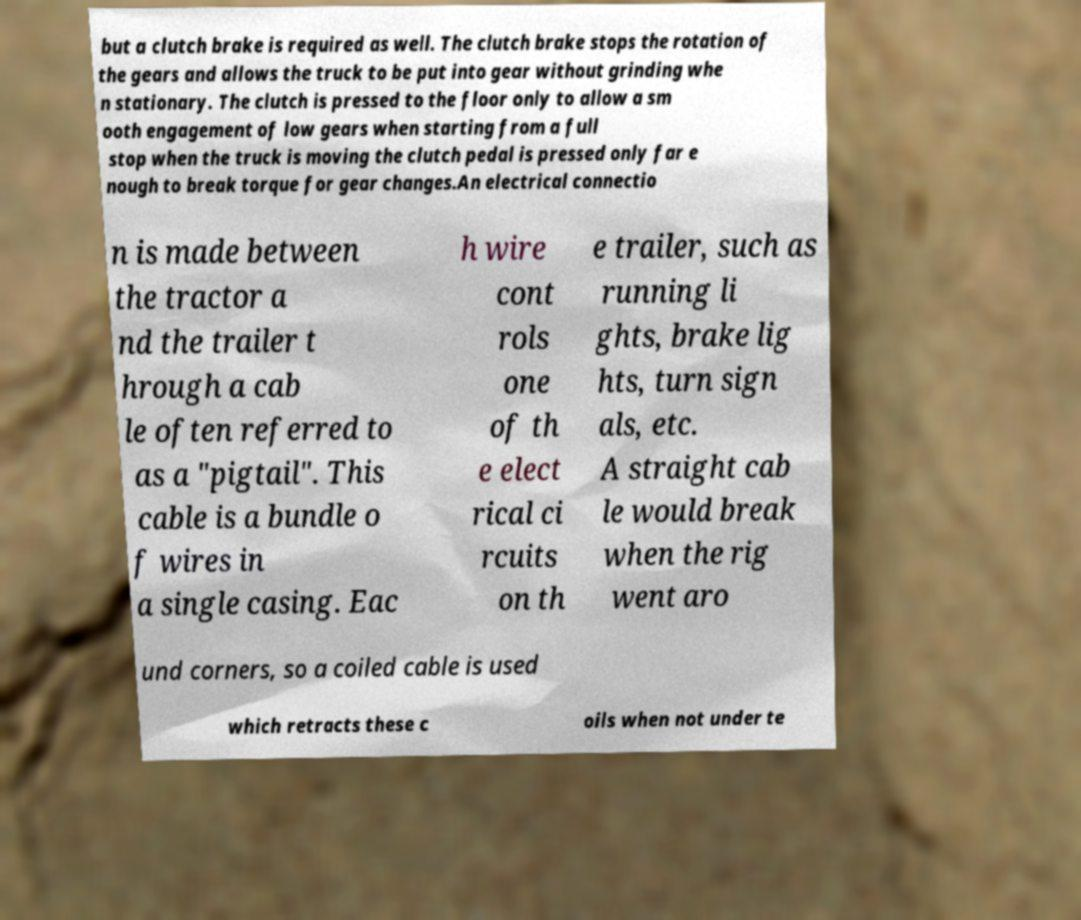Please read and relay the text visible in this image. What does it say? but a clutch brake is required as well. The clutch brake stops the rotation of the gears and allows the truck to be put into gear without grinding whe n stationary. The clutch is pressed to the floor only to allow a sm ooth engagement of low gears when starting from a full stop when the truck is moving the clutch pedal is pressed only far e nough to break torque for gear changes.An electrical connectio n is made between the tractor a nd the trailer t hrough a cab le often referred to as a "pigtail". This cable is a bundle o f wires in a single casing. Eac h wire cont rols one of th e elect rical ci rcuits on th e trailer, such as running li ghts, brake lig hts, turn sign als, etc. A straight cab le would break when the rig went aro und corners, so a coiled cable is used which retracts these c oils when not under te 